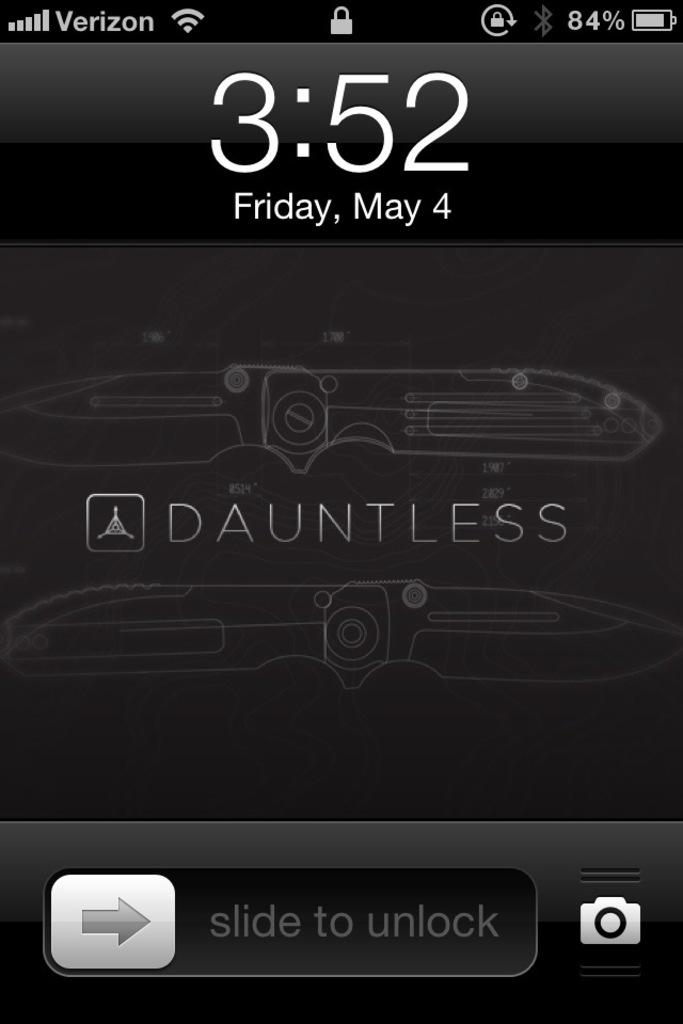What is the name of the cooking company?
Offer a very short reply. Dauntless. What time is shown?
Provide a short and direct response. 3:52. 